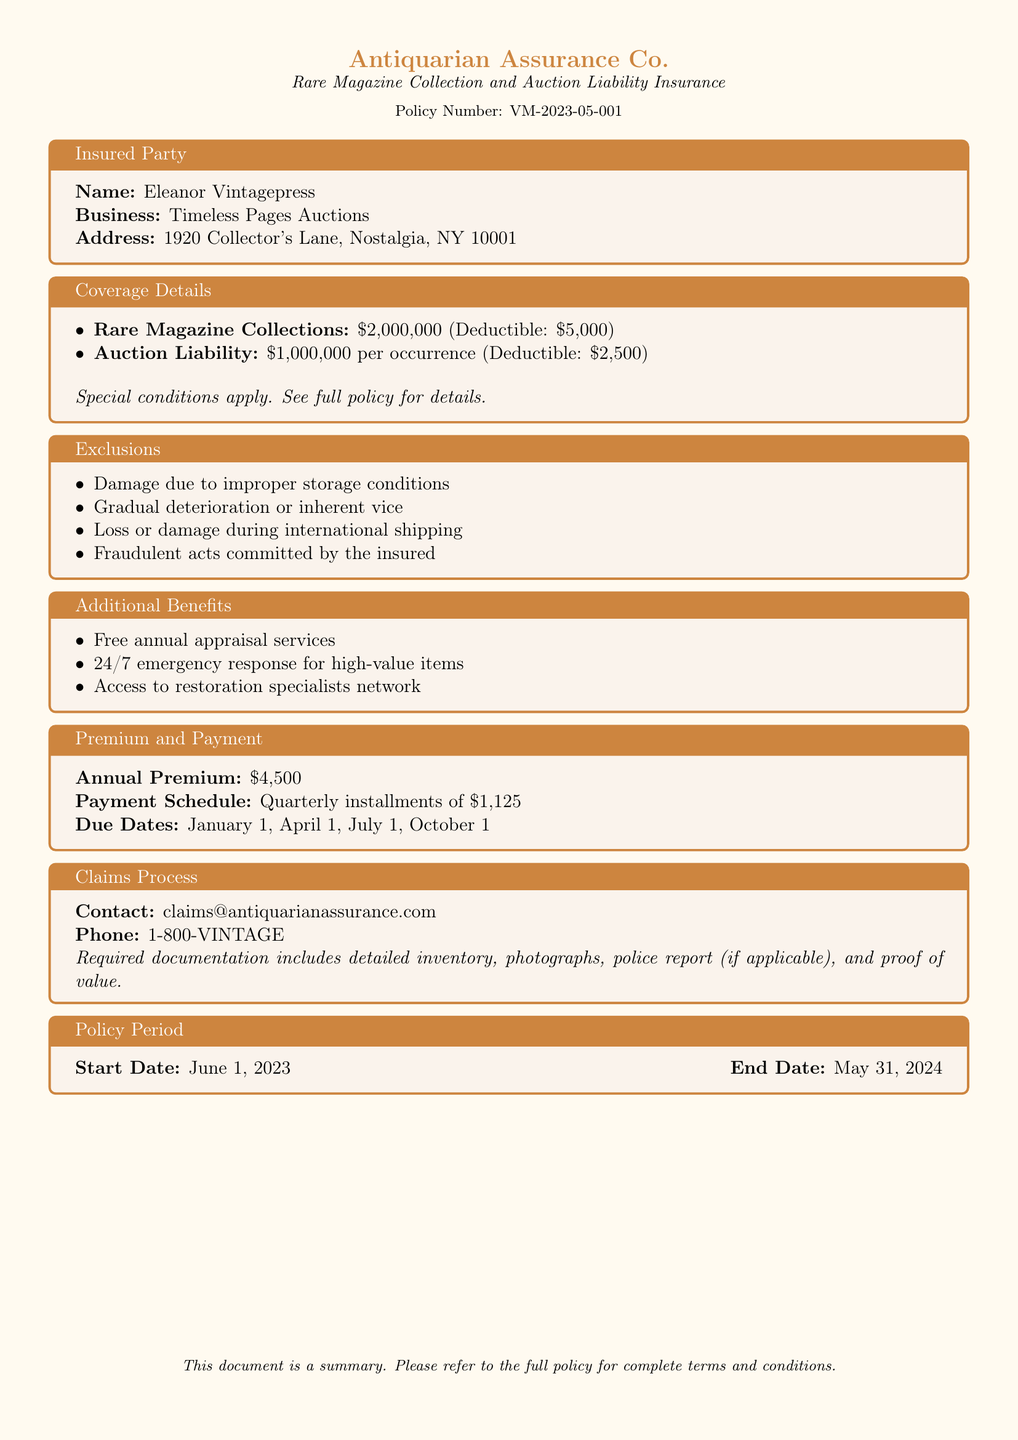What is the policy number? The policy number is indicated in the document title section.
Answer: VM-2023-05-001 What is the annual premium amount? The document states the annual premium in the Premium and Payment section.
Answer: $4,500 What is the deductible for rare magazine collections? The document specifies the deductible in the Coverage Details section.
Answer: $5,000 Who is the insured party? The insured party's name is provided at the beginning of the document.
Answer: Eleanor Vintagepress What is the liability coverage per occurrence? The liability coverage is mentioned in the Coverage Details section.
Answer: $1,000,000 What are the due dates for the quarterly premium payments? The document lists the payment schedule and its due dates.
Answer: January 1, April 1, July 1, October 1 What is excluded from the coverage? The document lists exclusions in a dedicated section.
Answer: Damage due to improper storage conditions What is the start date of the policy? The start date is provided in the Policy Period section.
Answer: June 1, 2023 What additional benefit is offered for high-value items? The document mentions specific additional benefits provided to the insured.
Answer: 24/7 emergency response for high-value items 